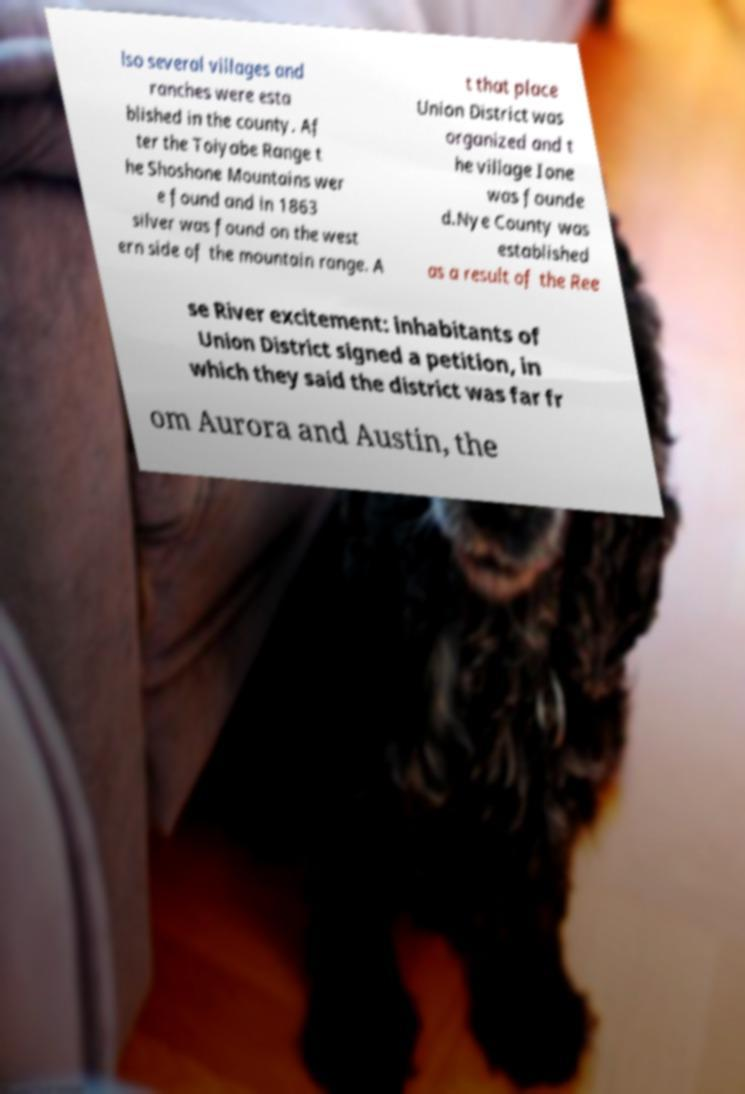Please identify and transcribe the text found in this image. lso several villages and ranches were esta blished in the county. Af ter the Toiyabe Range t he Shoshone Mountains wer e found and in 1863 silver was found on the west ern side of the mountain range. A t that place Union District was organized and t he village Ione was founde d.Nye County was established as a result of the Ree se River excitement: inhabitants of Union District signed a petition, in which they said the district was far fr om Aurora and Austin, the 